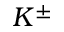<formula> <loc_0><loc_0><loc_500><loc_500>K ^ { \pm }</formula> 